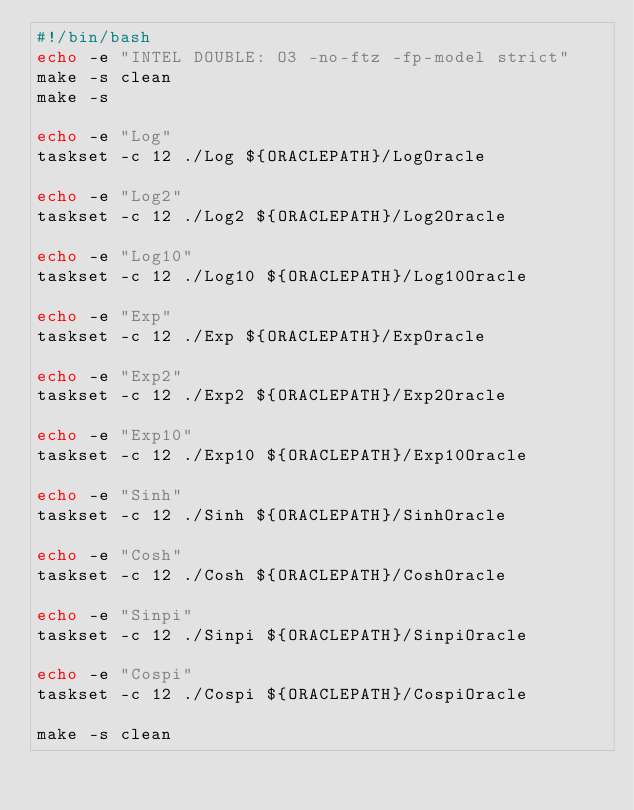<code> <loc_0><loc_0><loc_500><loc_500><_Bash_>#!/bin/bash
echo -e "INTEL DOUBLE: O3 -no-ftz -fp-model strict"
make -s clean
make -s

echo -e "Log"
taskset -c 12 ./Log ${ORACLEPATH}/LogOracle

echo -e "Log2"
taskset -c 12 ./Log2 ${ORACLEPATH}/Log2Oracle

echo -e "Log10"
taskset -c 12 ./Log10 ${ORACLEPATH}/Log10Oracle

echo -e "Exp"
taskset -c 12 ./Exp ${ORACLEPATH}/ExpOracle

echo -e "Exp2"
taskset -c 12 ./Exp2 ${ORACLEPATH}/Exp2Oracle

echo -e "Exp10"
taskset -c 12 ./Exp10 ${ORACLEPATH}/Exp10Oracle

echo -e "Sinh"
taskset -c 12 ./Sinh ${ORACLEPATH}/SinhOracle

echo -e "Cosh"
taskset -c 12 ./Cosh ${ORACLEPATH}/CoshOracle

echo -e "Sinpi"
taskset -c 12 ./Sinpi ${ORACLEPATH}/SinpiOracle

echo -e "Cospi"
taskset -c 12 ./Cospi ${ORACLEPATH}/CospiOracle

make -s clean
</code> 